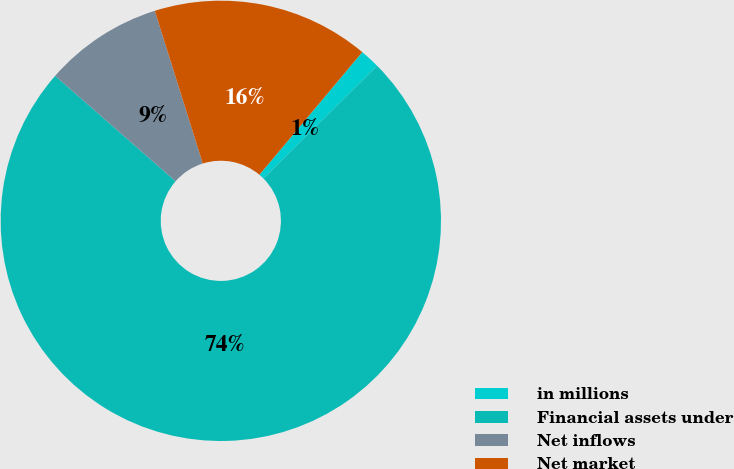Convert chart to OTSL. <chart><loc_0><loc_0><loc_500><loc_500><pie_chart><fcel>in millions<fcel>Financial assets under<fcel>Net inflows<fcel>Net market<nl><fcel>1.46%<fcel>73.88%<fcel>8.71%<fcel>15.95%<nl></chart> 